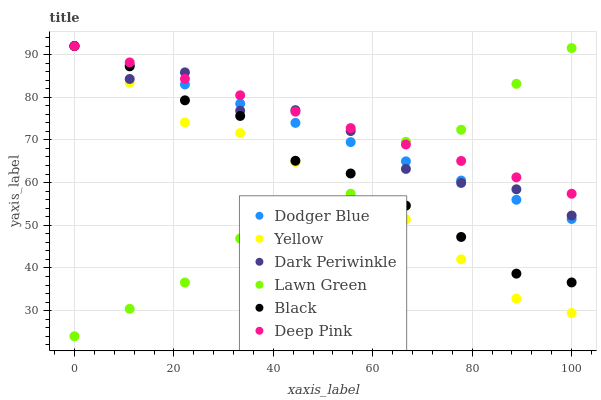Does Lawn Green have the minimum area under the curve?
Answer yes or no. Yes. Does Deep Pink have the maximum area under the curve?
Answer yes or no. Yes. Does Yellow have the minimum area under the curve?
Answer yes or no. No. Does Yellow have the maximum area under the curve?
Answer yes or no. No. Is Deep Pink the smoothest?
Answer yes or no. Yes. Is Dark Periwinkle the roughest?
Answer yes or no. Yes. Is Yellow the smoothest?
Answer yes or no. No. Is Yellow the roughest?
Answer yes or no. No. Does Lawn Green have the lowest value?
Answer yes or no. Yes. Does Yellow have the lowest value?
Answer yes or no. No. Does Dark Periwinkle have the highest value?
Answer yes or no. Yes. Does Deep Pink intersect Black?
Answer yes or no. Yes. Is Deep Pink less than Black?
Answer yes or no. No. Is Deep Pink greater than Black?
Answer yes or no. No. 